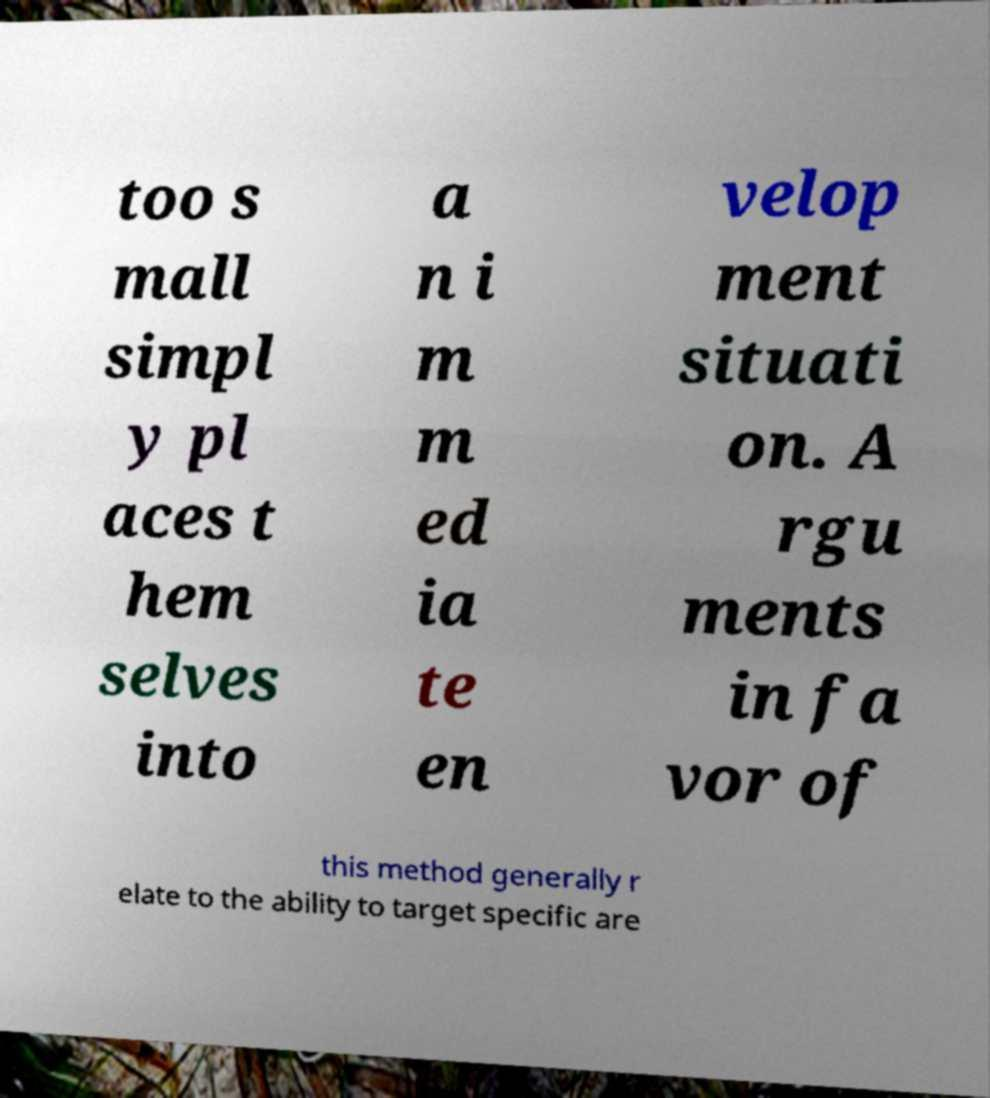There's text embedded in this image that I need extracted. Can you transcribe it verbatim? too s mall simpl y pl aces t hem selves into a n i m m ed ia te en velop ment situati on. A rgu ments in fa vor of this method generally r elate to the ability to target specific are 